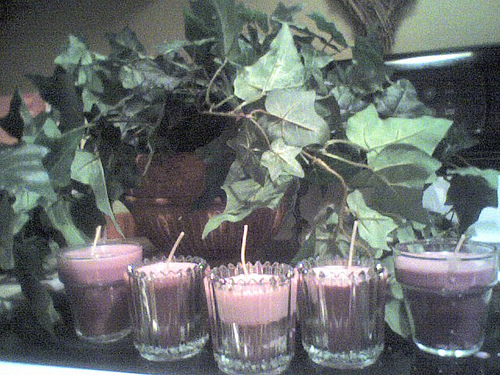<image>
Is the juice under the leaves? Yes. The juice is positioned underneath the leaves, with the leaves above it in the vertical space. 